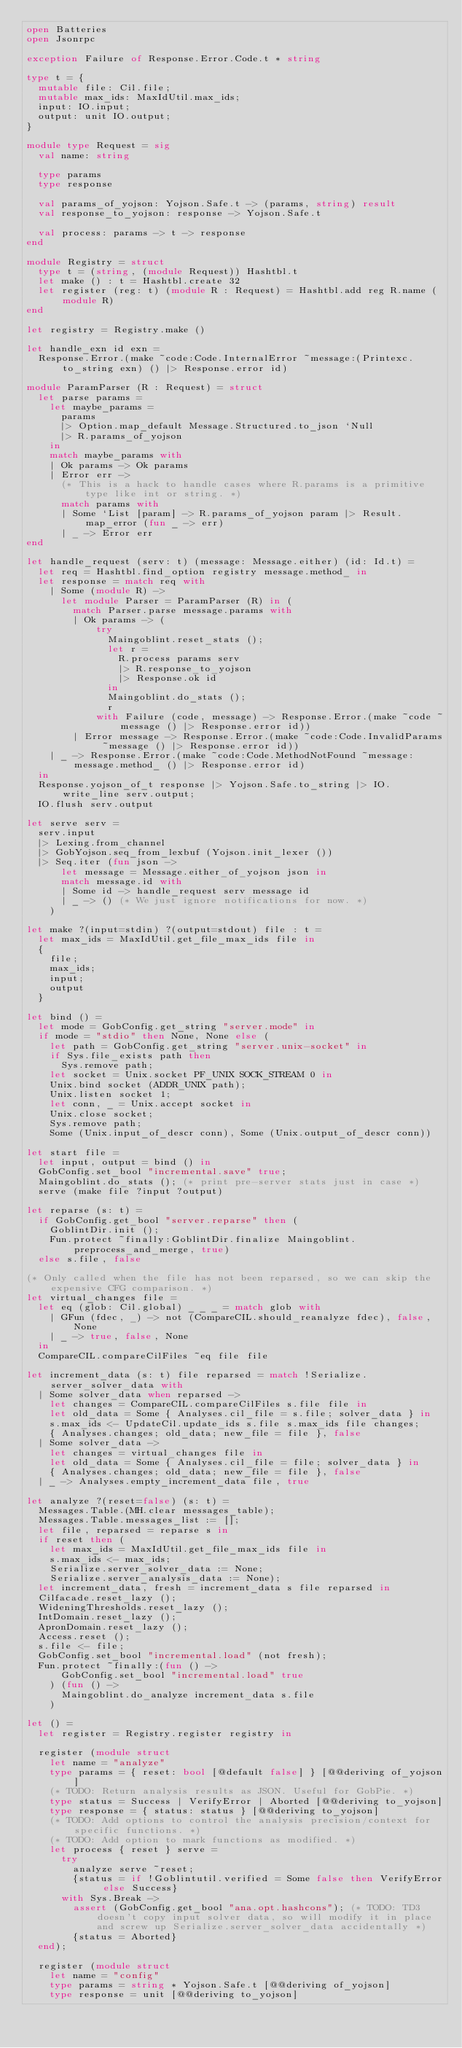<code> <loc_0><loc_0><loc_500><loc_500><_OCaml_>open Batteries
open Jsonrpc

exception Failure of Response.Error.Code.t * string

type t = {
  mutable file: Cil.file;
  mutable max_ids: MaxIdUtil.max_ids;
  input: IO.input;
  output: unit IO.output;
}

module type Request = sig
  val name: string

  type params
  type response

  val params_of_yojson: Yojson.Safe.t -> (params, string) result
  val response_to_yojson: response -> Yojson.Safe.t

  val process: params -> t -> response
end

module Registry = struct
  type t = (string, (module Request)) Hashtbl.t
  let make () : t = Hashtbl.create 32
  let register (reg: t) (module R : Request) = Hashtbl.add reg R.name (module R)
end

let registry = Registry.make ()

let handle_exn id exn =
  Response.Error.(make ~code:Code.InternalError ~message:(Printexc.to_string exn) () |> Response.error id)

module ParamParser (R : Request) = struct
  let parse params =
    let maybe_params =
      params
      |> Option.map_default Message.Structured.to_json `Null
      |> R.params_of_yojson
    in
    match maybe_params with
    | Ok params -> Ok params
    | Error err ->
      (* This is a hack to handle cases where R.params is a primitive type like int or string. *)
      match params with
      | Some `List [param] -> R.params_of_yojson param |> Result.map_error (fun _ -> err)
      | _ -> Error err
end

let handle_request (serv: t) (message: Message.either) (id: Id.t) =
  let req = Hashtbl.find_option registry message.method_ in
  let response = match req with
    | Some (module R) ->
      let module Parser = ParamParser (R) in (
        match Parser.parse message.params with
        | Ok params -> (
            try
              Maingoblint.reset_stats ();
              let r =
                R.process params serv
                |> R.response_to_yojson
                |> Response.ok id
              in
              Maingoblint.do_stats ();
              r
            with Failure (code, message) -> Response.Error.(make ~code ~message () |> Response.error id))
        | Error message -> Response.Error.(make ~code:Code.InvalidParams ~message () |> Response.error id))
    | _ -> Response.Error.(make ~code:Code.MethodNotFound ~message:message.method_ () |> Response.error id)
  in
  Response.yojson_of_t response |> Yojson.Safe.to_string |> IO.write_line serv.output;
  IO.flush serv.output

let serve serv =
  serv.input
  |> Lexing.from_channel
  |> GobYojson.seq_from_lexbuf (Yojson.init_lexer ())
  |> Seq.iter (fun json ->
      let message = Message.either_of_yojson json in
      match message.id with
      | Some id -> handle_request serv message id
      | _ -> () (* We just ignore notifications for now. *)
    )

let make ?(input=stdin) ?(output=stdout) file : t =
  let max_ids = MaxIdUtil.get_file_max_ids file in
  {
    file;
    max_ids;
    input;
    output
  }

let bind () =
  let mode = GobConfig.get_string "server.mode" in
  if mode = "stdio" then None, None else (
    let path = GobConfig.get_string "server.unix-socket" in
    if Sys.file_exists path then
      Sys.remove path;
    let socket = Unix.socket PF_UNIX SOCK_STREAM 0 in
    Unix.bind socket (ADDR_UNIX path);
    Unix.listen socket 1;
    let conn, _ = Unix.accept socket in
    Unix.close socket;
    Sys.remove path;
    Some (Unix.input_of_descr conn), Some (Unix.output_of_descr conn))

let start file =
  let input, output = bind () in
  GobConfig.set_bool "incremental.save" true;
  Maingoblint.do_stats (); (* print pre-server stats just in case *)
  serve (make file ?input ?output)

let reparse (s: t) =
  if GobConfig.get_bool "server.reparse" then (
    GoblintDir.init ();
    Fun.protect ~finally:GoblintDir.finalize Maingoblint.preprocess_and_merge, true)
  else s.file, false

(* Only called when the file has not been reparsed, so we can skip the expensive CFG comparison. *)
let virtual_changes file =
  let eq (glob: Cil.global) _ _ _ = match glob with
    | GFun (fdec, _) -> not (CompareCIL.should_reanalyze fdec), false, None
    | _ -> true, false, None
  in
  CompareCIL.compareCilFiles ~eq file file

let increment_data (s: t) file reparsed = match !Serialize.server_solver_data with
  | Some solver_data when reparsed ->
    let changes = CompareCIL.compareCilFiles s.file file in
    let old_data = Some { Analyses.cil_file = s.file; solver_data } in
    s.max_ids <- UpdateCil.update_ids s.file s.max_ids file changes;
    { Analyses.changes; old_data; new_file = file }, false
  | Some solver_data ->
    let changes = virtual_changes file in
    let old_data = Some { Analyses.cil_file = file; solver_data } in
    { Analyses.changes; old_data; new_file = file }, false
  | _ -> Analyses.empty_increment_data file, true

let analyze ?(reset=false) (s: t) =
  Messages.Table.(MH.clear messages_table);
  Messages.Table.messages_list := [];
  let file, reparsed = reparse s in
  if reset then (
    let max_ids = MaxIdUtil.get_file_max_ids file in
    s.max_ids <- max_ids;
    Serialize.server_solver_data := None;
    Serialize.server_analysis_data := None);
  let increment_data, fresh = increment_data s file reparsed in
  Cilfacade.reset_lazy ();
  WideningThresholds.reset_lazy ();
  IntDomain.reset_lazy ();
  ApronDomain.reset_lazy ();
  Access.reset ();
  s.file <- file;
  GobConfig.set_bool "incremental.load" (not fresh);
  Fun.protect ~finally:(fun () ->
      GobConfig.set_bool "incremental.load" true
    ) (fun () ->
      Maingoblint.do_analyze increment_data s.file
    )

let () =
  let register = Registry.register registry in

  register (module struct
    let name = "analyze"
    type params = { reset: bool [@default false] } [@@deriving of_yojson]
    (* TODO: Return analysis results as JSON. Useful for GobPie. *)
    type status = Success | VerifyError | Aborted [@@deriving to_yojson]
    type response = { status: status } [@@deriving to_yojson]
    (* TODO: Add options to control the analysis precision/context for specific functions. *)
    (* TODO: Add option to mark functions as modified. *)
    let process { reset } serve =
      try
        analyze serve ~reset;
        {status = if !Goblintutil.verified = Some false then VerifyError else Success}
      with Sys.Break ->
        assert (GobConfig.get_bool "ana.opt.hashcons"); (* TODO: TD3 doesn't copy input solver data, so will modify it in place and screw up Serialize.server_solver_data accidentally *)
        {status = Aborted}
  end);

  register (module struct
    let name = "config"
    type params = string * Yojson.Safe.t [@@deriving of_yojson]
    type response = unit [@@deriving to_yojson]</code> 